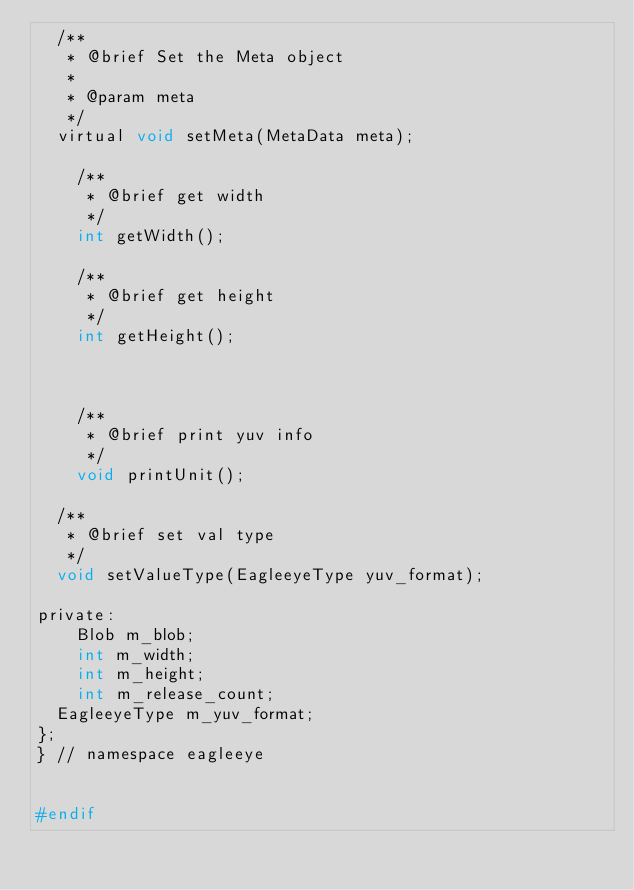Convert code to text. <code><loc_0><loc_0><loc_500><loc_500><_C_>	/**
	 * @brief Set the Meta object
	 * 
	 * @param meta 
	 */
	virtual void setMeta(MetaData meta);

    /**
     * @brief get width
     */ 
    int getWidth();

    /**
     * @brief get height
     */ 
    int getHeight();

	

    /**
     * @brief print yuv info
     */ 
    void printUnit();

	/**
	 * @brief set val type
	 */ 
	void setValueType(EagleeyeType yuv_format);

private:
    Blob m_blob;
    int m_width;
    int m_height;
    int m_release_count;
	EagleeyeType m_yuv_format;
};
} // namespace eagleeye


#endif</code> 